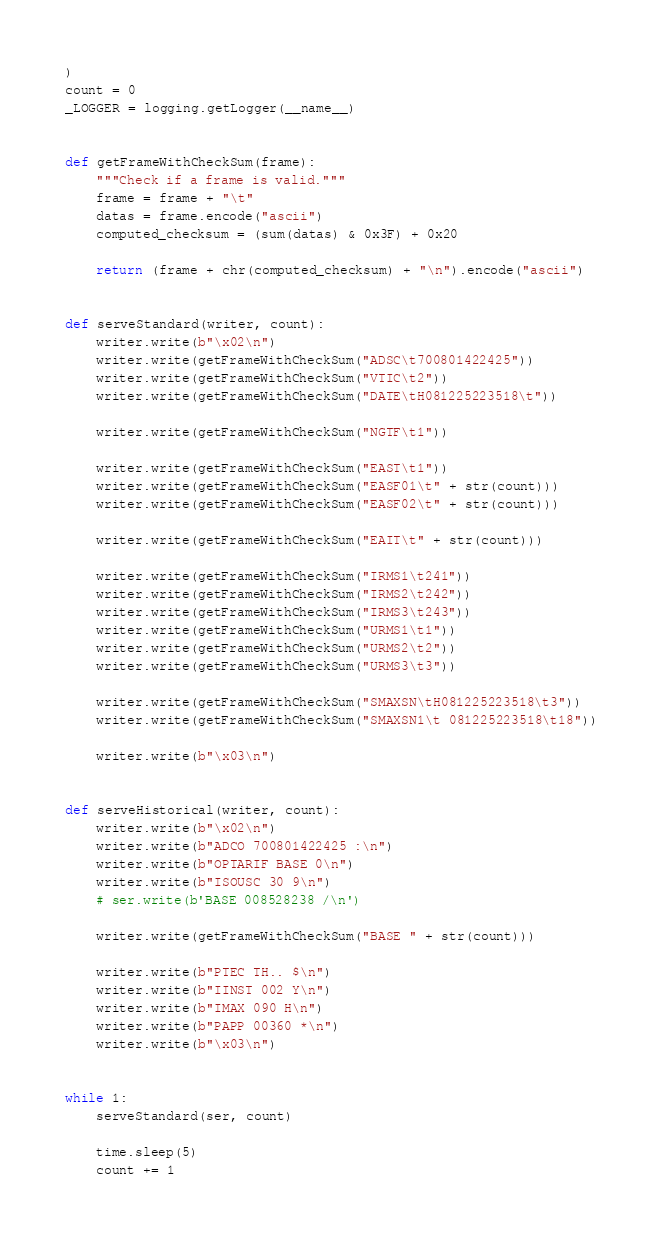<code> <loc_0><loc_0><loc_500><loc_500><_Python_>)
count = 0
_LOGGER = logging.getLogger(__name__)


def getFrameWithCheckSum(frame):
    """Check if a frame is valid."""
    frame = frame + "\t"
    datas = frame.encode("ascii")
    computed_checksum = (sum(datas) & 0x3F) + 0x20

    return (frame + chr(computed_checksum) + "\n").encode("ascii")


def serveStandard(writer, count):
    writer.write(b"\x02\n")
    writer.write(getFrameWithCheckSum("ADSC\t700801422425"))
    writer.write(getFrameWithCheckSum("VTIC\t2"))
    writer.write(getFrameWithCheckSum("DATE\tH081225223518\t"))

    writer.write(getFrameWithCheckSum("NGTF\t1"))

    writer.write(getFrameWithCheckSum("EAST\t1"))
    writer.write(getFrameWithCheckSum("EASF01\t" + str(count)))
    writer.write(getFrameWithCheckSum("EASF02\t" + str(count)))

    writer.write(getFrameWithCheckSum("EAIT\t" + str(count)))

    writer.write(getFrameWithCheckSum("IRMS1\t241"))
    writer.write(getFrameWithCheckSum("IRMS2\t242"))
    writer.write(getFrameWithCheckSum("IRMS3\t243"))
    writer.write(getFrameWithCheckSum("URMS1\t1"))
    writer.write(getFrameWithCheckSum("URMS2\t2"))
    writer.write(getFrameWithCheckSum("URMS3\t3"))

    writer.write(getFrameWithCheckSum("SMAXSN\tH081225223518\t3"))
    writer.write(getFrameWithCheckSum("SMAXSN1\t 081225223518\t18"))

    writer.write(b"\x03\n")


def serveHistorical(writer, count):
    writer.write(b"\x02\n")
    writer.write(b"ADCO 700801422425 :\n")
    writer.write(b"OPTARIF BASE 0\n")
    writer.write(b"ISOUSC 30 9\n")
    # ser.write(b'BASE 008528238 /\n')

    writer.write(getFrameWithCheckSum("BASE " + str(count)))

    writer.write(b"PTEC TH.. $\n")
    writer.write(b"IINST 002 Y\n")
    writer.write(b"IMAX 090 H\n")
    writer.write(b"PAPP 00360 *\n")
    writer.write(b"\x03\n")


while 1:
    serveStandard(ser, count)

    time.sleep(5)
    count += 1
</code> 